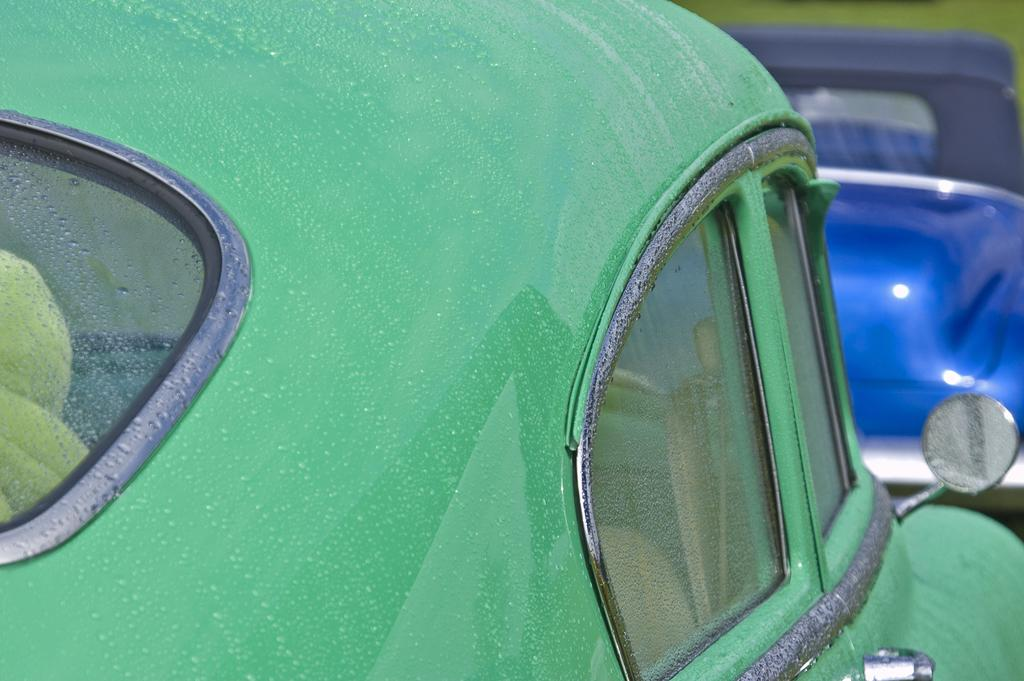What colors are the vehicles in the image? The vehicles in the image are green and blue. Can you describe any other objects in the image besides the vehicles? There are other objects in the image, but their specific details are not mentioned in the provided facts. How many brothers are playing with the green vehicles in the image? There is no mention of brothers or any people playing with the vehicles in the image. 